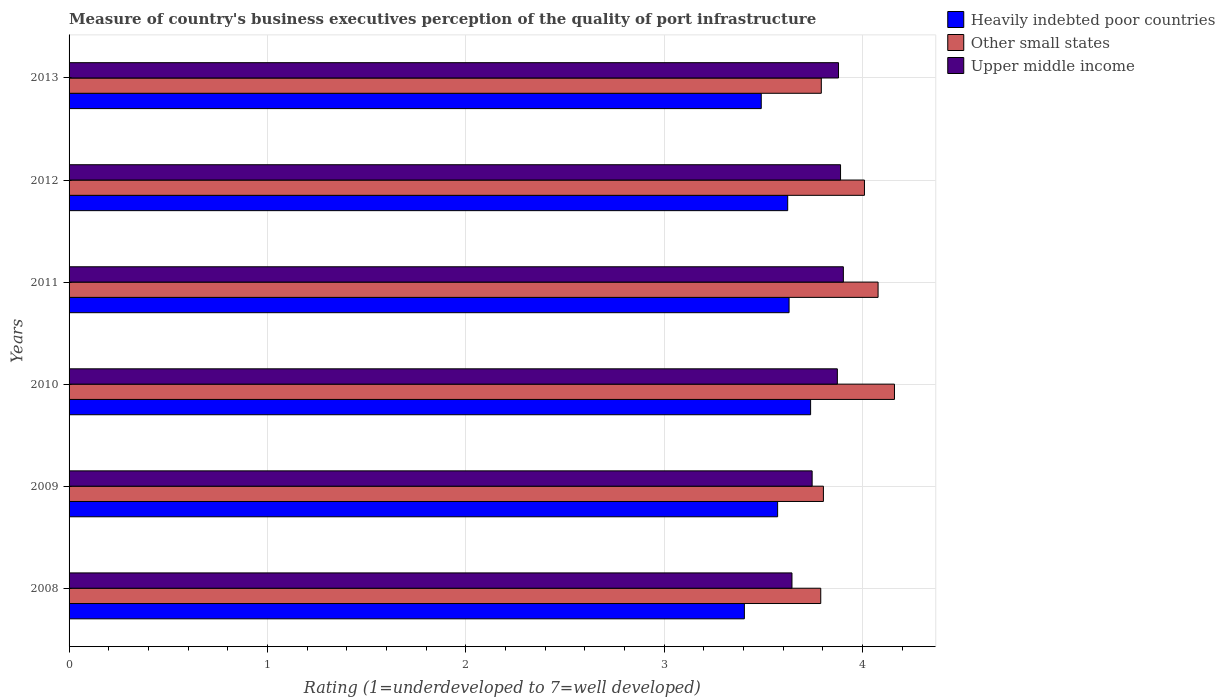How many different coloured bars are there?
Your answer should be very brief. 3. How many bars are there on the 5th tick from the top?
Your answer should be compact. 3. What is the label of the 6th group of bars from the top?
Your answer should be compact. 2008. What is the ratings of the quality of port infrastructure in Heavily indebted poor countries in 2011?
Your response must be concise. 3.63. Across all years, what is the maximum ratings of the quality of port infrastructure in Other small states?
Ensure brevity in your answer.  4.16. Across all years, what is the minimum ratings of the quality of port infrastructure in Upper middle income?
Keep it short and to the point. 3.64. In which year was the ratings of the quality of port infrastructure in Upper middle income maximum?
Your answer should be compact. 2011. What is the total ratings of the quality of port infrastructure in Other small states in the graph?
Keep it short and to the point. 23.63. What is the difference between the ratings of the quality of port infrastructure in Upper middle income in 2009 and that in 2011?
Offer a terse response. -0.16. What is the difference between the ratings of the quality of port infrastructure in Heavily indebted poor countries in 2009 and the ratings of the quality of port infrastructure in Upper middle income in 2012?
Your answer should be compact. -0.32. What is the average ratings of the quality of port infrastructure in Other small states per year?
Keep it short and to the point. 3.94. In the year 2011, what is the difference between the ratings of the quality of port infrastructure in Other small states and ratings of the quality of port infrastructure in Upper middle income?
Provide a succinct answer. 0.17. What is the ratio of the ratings of the quality of port infrastructure in Other small states in 2009 to that in 2010?
Your answer should be compact. 0.91. What is the difference between the highest and the second highest ratings of the quality of port infrastructure in Upper middle income?
Keep it short and to the point. 0.01. What is the difference between the highest and the lowest ratings of the quality of port infrastructure in Other small states?
Your response must be concise. 0.37. In how many years, is the ratings of the quality of port infrastructure in Other small states greater than the average ratings of the quality of port infrastructure in Other small states taken over all years?
Provide a succinct answer. 3. Is the sum of the ratings of the quality of port infrastructure in Upper middle income in 2009 and 2010 greater than the maximum ratings of the quality of port infrastructure in Other small states across all years?
Your response must be concise. Yes. What does the 1st bar from the top in 2011 represents?
Provide a succinct answer. Upper middle income. What does the 1st bar from the bottom in 2011 represents?
Give a very brief answer. Heavily indebted poor countries. What is the difference between two consecutive major ticks on the X-axis?
Ensure brevity in your answer.  1. Are the values on the major ticks of X-axis written in scientific E-notation?
Provide a short and direct response. No. Where does the legend appear in the graph?
Your answer should be very brief. Top right. How many legend labels are there?
Give a very brief answer. 3. What is the title of the graph?
Your answer should be very brief. Measure of country's business executives perception of the quality of port infrastructure. What is the label or title of the X-axis?
Provide a succinct answer. Rating (1=underdeveloped to 7=well developed). What is the label or title of the Y-axis?
Your answer should be compact. Years. What is the Rating (1=underdeveloped to 7=well developed) of Heavily indebted poor countries in 2008?
Your answer should be very brief. 3.4. What is the Rating (1=underdeveloped to 7=well developed) in Other small states in 2008?
Give a very brief answer. 3.79. What is the Rating (1=underdeveloped to 7=well developed) in Upper middle income in 2008?
Keep it short and to the point. 3.64. What is the Rating (1=underdeveloped to 7=well developed) in Heavily indebted poor countries in 2009?
Offer a terse response. 3.57. What is the Rating (1=underdeveloped to 7=well developed) in Other small states in 2009?
Keep it short and to the point. 3.8. What is the Rating (1=underdeveloped to 7=well developed) of Upper middle income in 2009?
Give a very brief answer. 3.75. What is the Rating (1=underdeveloped to 7=well developed) of Heavily indebted poor countries in 2010?
Offer a very short reply. 3.74. What is the Rating (1=underdeveloped to 7=well developed) in Other small states in 2010?
Make the answer very short. 4.16. What is the Rating (1=underdeveloped to 7=well developed) in Upper middle income in 2010?
Your answer should be very brief. 3.87. What is the Rating (1=underdeveloped to 7=well developed) in Heavily indebted poor countries in 2011?
Your answer should be very brief. 3.63. What is the Rating (1=underdeveloped to 7=well developed) in Other small states in 2011?
Your answer should be very brief. 4.08. What is the Rating (1=underdeveloped to 7=well developed) in Upper middle income in 2011?
Keep it short and to the point. 3.9. What is the Rating (1=underdeveloped to 7=well developed) in Heavily indebted poor countries in 2012?
Your answer should be very brief. 3.62. What is the Rating (1=underdeveloped to 7=well developed) in Other small states in 2012?
Your answer should be very brief. 4.01. What is the Rating (1=underdeveloped to 7=well developed) of Upper middle income in 2012?
Your response must be concise. 3.89. What is the Rating (1=underdeveloped to 7=well developed) of Heavily indebted poor countries in 2013?
Your answer should be compact. 3.49. What is the Rating (1=underdeveloped to 7=well developed) of Other small states in 2013?
Your answer should be very brief. 3.79. What is the Rating (1=underdeveloped to 7=well developed) of Upper middle income in 2013?
Your answer should be compact. 3.88. Across all years, what is the maximum Rating (1=underdeveloped to 7=well developed) in Heavily indebted poor countries?
Give a very brief answer. 3.74. Across all years, what is the maximum Rating (1=underdeveloped to 7=well developed) in Other small states?
Your answer should be very brief. 4.16. Across all years, what is the maximum Rating (1=underdeveloped to 7=well developed) of Upper middle income?
Offer a terse response. 3.9. Across all years, what is the minimum Rating (1=underdeveloped to 7=well developed) of Heavily indebted poor countries?
Give a very brief answer. 3.4. Across all years, what is the minimum Rating (1=underdeveloped to 7=well developed) of Other small states?
Provide a succinct answer. 3.79. Across all years, what is the minimum Rating (1=underdeveloped to 7=well developed) of Upper middle income?
Provide a short and direct response. 3.64. What is the total Rating (1=underdeveloped to 7=well developed) in Heavily indebted poor countries in the graph?
Offer a terse response. 21.45. What is the total Rating (1=underdeveloped to 7=well developed) in Other small states in the graph?
Your response must be concise. 23.63. What is the total Rating (1=underdeveloped to 7=well developed) in Upper middle income in the graph?
Your response must be concise. 22.93. What is the difference between the Rating (1=underdeveloped to 7=well developed) in Heavily indebted poor countries in 2008 and that in 2009?
Provide a succinct answer. -0.17. What is the difference between the Rating (1=underdeveloped to 7=well developed) in Other small states in 2008 and that in 2009?
Your answer should be compact. -0.01. What is the difference between the Rating (1=underdeveloped to 7=well developed) in Upper middle income in 2008 and that in 2009?
Your answer should be compact. -0.1. What is the difference between the Rating (1=underdeveloped to 7=well developed) of Heavily indebted poor countries in 2008 and that in 2010?
Your response must be concise. -0.33. What is the difference between the Rating (1=underdeveloped to 7=well developed) of Other small states in 2008 and that in 2010?
Ensure brevity in your answer.  -0.37. What is the difference between the Rating (1=underdeveloped to 7=well developed) of Upper middle income in 2008 and that in 2010?
Ensure brevity in your answer.  -0.23. What is the difference between the Rating (1=underdeveloped to 7=well developed) in Heavily indebted poor countries in 2008 and that in 2011?
Offer a very short reply. -0.23. What is the difference between the Rating (1=underdeveloped to 7=well developed) of Other small states in 2008 and that in 2011?
Your response must be concise. -0.29. What is the difference between the Rating (1=underdeveloped to 7=well developed) in Upper middle income in 2008 and that in 2011?
Ensure brevity in your answer.  -0.26. What is the difference between the Rating (1=underdeveloped to 7=well developed) in Heavily indebted poor countries in 2008 and that in 2012?
Your response must be concise. -0.22. What is the difference between the Rating (1=underdeveloped to 7=well developed) in Other small states in 2008 and that in 2012?
Offer a very short reply. -0.22. What is the difference between the Rating (1=underdeveloped to 7=well developed) of Upper middle income in 2008 and that in 2012?
Offer a terse response. -0.24. What is the difference between the Rating (1=underdeveloped to 7=well developed) of Heavily indebted poor countries in 2008 and that in 2013?
Give a very brief answer. -0.09. What is the difference between the Rating (1=underdeveloped to 7=well developed) in Other small states in 2008 and that in 2013?
Keep it short and to the point. -0. What is the difference between the Rating (1=underdeveloped to 7=well developed) in Upper middle income in 2008 and that in 2013?
Offer a very short reply. -0.23. What is the difference between the Rating (1=underdeveloped to 7=well developed) of Heavily indebted poor countries in 2009 and that in 2010?
Keep it short and to the point. -0.17. What is the difference between the Rating (1=underdeveloped to 7=well developed) in Other small states in 2009 and that in 2010?
Keep it short and to the point. -0.36. What is the difference between the Rating (1=underdeveloped to 7=well developed) of Upper middle income in 2009 and that in 2010?
Provide a succinct answer. -0.13. What is the difference between the Rating (1=underdeveloped to 7=well developed) in Heavily indebted poor countries in 2009 and that in 2011?
Offer a very short reply. -0.06. What is the difference between the Rating (1=underdeveloped to 7=well developed) in Other small states in 2009 and that in 2011?
Offer a very short reply. -0.28. What is the difference between the Rating (1=underdeveloped to 7=well developed) in Upper middle income in 2009 and that in 2011?
Provide a succinct answer. -0.16. What is the difference between the Rating (1=underdeveloped to 7=well developed) of Heavily indebted poor countries in 2009 and that in 2012?
Provide a succinct answer. -0.05. What is the difference between the Rating (1=underdeveloped to 7=well developed) of Other small states in 2009 and that in 2012?
Your answer should be compact. -0.21. What is the difference between the Rating (1=underdeveloped to 7=well developed) of Upper middle income in 2009 and that in 2012?
Ensure brevity in your answer.  -0.14. What is the difference between the Rating (1=underdeveloped to 7=well developed) in Heavily indebted poor countries in 2009 and that in 2013?
Your response must be concise. 0.08. What is the difference between the Rating (1=underdeveloped to 7=well developed) of Other small states in 2009 and that in 2013?
Offer a terse response. 0.01. What is the difference between the Rating (1=underdeveloped to 7=well developed) of Upper middle income in 2009 and that in 2013?
Keep it short and to the point. -0.13. What is the difference between the Rating (1=underdeveloped to 7=well developed) of Heavily indebted poor countries in 2010 and that in 2011?
Offer a very short reply. 0.11. What is the difference between the Rating (1=underdeveloped to 7=well developed) in Other small states in 2010 and that in 2011?
Your answer should be compact. 0.08. What is the difference between the Rating (1=underdeveloped to 7=well developed) of Upper middle income in 2010 and that in 2011?
Offer a terse response. -0.03. What is the difference between the Rating (1=underdeveloped to 7=well developed) in Heavily indebted poor countries in 2010 and that in 2012?
Keep it short and to the point. 0.12. What is the difference between the Rating (1=underdeveloped to 7=well developed) in Other small states in 2010 and that in 2012?
Your response must be concise. 0.15. What is the difference between the Rating (1=underdeveloped to 7=well developed) in Upper middle income in 2010 and that in 2012?
Your answer should be compact. -0.02. What is the difference between the Rating (1=underdeveloped to 7=well developed) in Heavily indebted poor countries in 2010 and that in 2013?
Provide a succinct answer. 0.25. What is the difference between the Rating (1=underdeveloped to 7=well developed) of Other small states in 2010 and that in 2013?
Keep it short and to the point. 0.37. What is the difference between the Rating (1=underdeveloped to 7=well developed) of Upper middle income in 2010 and that in 2013?
Your response must be concise. -0.01. What is the difference between the Rating (1=underdeveloped to 7=well developed) in Heavily indebted poor countries in 2011 and that in 2012?
Offer a terse response. 0.01. What is the difference between the Rating (1=underdeveloped to 7=well developed) in Other small states in 2011 and that in 2012?
Your answer should be very brief. 0.07. What is the difference between the Rating (1=underdeveloped to 7=well developed) of Upper middle income in 2011 and that in 2012?
Offer a very short reply. 0.01. What is the difference between the Rating (1=underdeveloped to 7=well developed) in Heavily indebted poor countries in 2011 and that in 2013?
Offer a very short reply. 0.14. What is the difference between the Rating (1=underdeveloped to 7=well developed) in Other small states in 2011 and that in 2013?
Make the answer very short. 0.29. What is the difference between the Rating (1=underdeveloped to 7=well developed) of Upper middle income in 2011 and that in 2013?
Give a very brief answer. 0.02. What is the difference between the Rating (1=underdeveloped to 7=well developed) of Heavily indebted poor countries in 2012 and that in 2013?
Your response must be concise. 0.13. What is the difference between the Rating (1=underdeveloped to 7=well developed) of Other small states in 2012 and that in 2013?
Ensure brevity in your answer.  0.22. What is the difference between the Rating (1=underdeveloped to 7=well developed) of Upper middle income in 2012 and that in 2013?
Your answer should be compact. 0.01. What is the difference between the Rating (1=underdeveloped to 7=well developed) of Heavily indebted poor countries in 2008 and the Rating (1=underdeveloped to 7=well developed) of Other small states in 2009?
Give a very brief answer. -0.4. What is the difference between the Rating (1=underdeveloped to 7=well developed) of Heavily indebted poor countries in 2008 and the Rating (1=underdeveloped to 7=well developed) of Upper middle income in 2009?
Your answer should be compact. -0.34. What is the difference between the Rating (1=underdeveloped to 7=well developed) in Other small states in 2008 and the Rating (1=underdeveloped to 7=well developed) in Upper middle income in 2009?
Keep it short and to the point. 0.04. What is the difference between the Rating (1=underdeveloped to 7=well developed) in Heavily indebted poor countries in 2008 and the Rating (1=underdeveloped to 7=well developed) in Other small states in 2010?
Make the answer very short. -0.76. What is the difference between the Rating (1=underdeveloped to 7=well developed) in Heavily indebted poor countries in 2008 and the Rating (1=underdeveloped to 7=well developed) in Upper middle income in 2010?
Your response must be concise. -0.47. What is the difference between the Rating (1=underdeveloped to 7=well developed) in Other small states in 2008 and the Rating (1=underdeveloped to 7=well developed) in Upper middle income in 2010?
Ensure brevity in your answer.  -0.08. What is the difference between the Rating (1=underdeveloped to 7=well developed) of Heavily indebted poor countries in 2008 and the Rating (1=underdeveloped to 7=well developed) of Other small states in 2011?
Provide a succinct answer. -0.67. What is the difference between the Rating (1=underdeveloped to 7=well developed) of Heavily indebted poor countries in 2008 and the Rating (1=underdeveloped to 7=well developed) of Upper middle income in 2011?
Make the answer very short. -0.5. What is the difference between the Rating (1=underdeveloped to 7=well developed) of Other small states in 2008 and the Rating (1=underdeveloped to 7=well developed) of Upper middle income in 2011?
Give a very brief answer. -0.11. What is the difference between the Rating (1=underdeveloped to 7=well developed) of Heavily indebted poor countries in 2008 and the Rating (1=underdeveloped to 7=well developed) of Other small states in 2012?
Make the answer very short. -0.61. What is the difference between the Rating (1=underdeveloped to 7=well developed) in Heavily indebted poor countries in 2008 and the Rating (1=underdeveloped to 7=well developed) in Upper middle income in 2012?
Your response must be concise. -0.48. What is the difference between the Rating (1=underdeveloped to 7=well developed) of Other small states in 2008 and the Rating (1=underdeveloped to 7=well developed) of Upper middle income in 2012?
Your response must be concise. -0.1. What is the difference between the Rating (1=underdeveloped to 7=well developed) in Heavily indebted poor countries in 2008 and the Rating (1=underdeveloped to 7=well developed) in Other small states in 2013?
Provide a short and direct response. -0.39. What is the difference between the Rating (1=underdeveloped to 7=well developed) of Heavily indebted poor countries in 2008 and the Rating (1=underdeveloped to 7=well developed) of Upper middle income in 2013?
Provide a succinct answer. -0.47. What is the difference between the Rating (1=underdeveloped to 7=well developed) in Other small states in 2008 and the Rating (1=underdeveloped to 7=well developed) in Upper middle income in 2013?
Keep it short and to the point. -0.09. What is the difference between the Rating (1=underdeveloped to 7=well developed) in Heavily indebted poor countries in 2009 and the Rating (1=underdeveloped to 7=well developed) in Other small states in 2010?
Your answer should be very brief. -0.59. What is the difference between the Rating (1=underdeveloped to 7=well developed) of Heavily indebted poor countries in 2009 and the Rating (1=underdeveloped to 7=well developed) of Upper middle income in 2010?
Your answer should be very brief. -0.3. What is the difference between the Rating (1=underdeveloped to 7=well developed) in Other small states in 2009 and the Rating (1=underdeveloped to 7=well developed) in Upper middle income in 2010?
Make the answer very short. -0.07. What is the difference between the Rating (1=underdeveloped to 7=well developed) in Heavily indebted poor countries in 2009 and the Rating (1=underdeveloped to 7=well developed) in Other small states in 2011?
Give a very brief answer. -0.51. What is the difference between the Rating (1=underdeveloped to 7=well developed) of Heavily indebted poor countries in 2009 and the Rating (1=underdeveloped to 7=well developed) of Upper middle income in 2011?
Offer a terse response. -0.33. What is the difference between the Rating (1=underdeveloped to 7=well developed) of Other small states in 2009 and the Rating (1=underdeveloped to 7=well developed) of Upper middle income in 2011?
Your response must be concise. -0.1. What is the difference between the Rating (1=underdeveloped to 7=well developed) of Heavily indebted poor countries in 2009 and the Rating (1=underdeveloped to 7=well developed) of Other small states in 2012?
Your answer should be very brief. -0.44. What is the difference between the Rating (1=underdeveloped to 7=well developed) in Heavily indebted poor countries in 2009 and the Rating (1=underdeveloped to 7=well developed) in Upper middle income in 2012?
Provide a short and direct response. -0.32. What is the difference between the Rating (1=underdeveloped to 7=well developed) in Other small states in 2009 and the Rating (1=underdeveloped to 7=well developed) in Upper middle income in 2012?
Provide a short and direct response. -0.09. What is the difference between the Rating (1=underdeveloped to 7=well developed) in Heavily indebted poor countries in 2009 and the Rating (1=underdeveloped to 7=well developed) in Other small states in 2013?
Your response must be concise. -0.22. What is the difference between the Rating (1=underdeveloped to 7=well developed) of Heavily indebted poor countries in 2009 and the Rating (1=underdeveloped to 7=well developed) of Upper middle income in 2013?
Give a very brief answer. -0.31. What is the difference between the Rating (1=underdeveloped to 7=well developed) in Other small states in 2009 and the Rating (1=underdeveloped to 7=well developed) in Upper middle income in 2013?
Provide a succinct answer. -0.08. What is the difference between the Rating (1=underdeveloped to 7=well developed) in Heavily indebted poor countries in 2010 and the Rating (1=underdeveloped to 7=well developed) in Other small states in 2011?
Your answer should be compact. -0.34. What is the difference between the Rating (1=underdeveloped to 7=well developed) of Heavily indebted poor countries in 2010 and the Rating (1=underdeveloped to 7=well developed) of Upper middle income in 2011?
Your answer should be compact. -0.17. What is the difference between the Rating (1=underdeveloped to 7=well developed) in Other small states in 2010 and the Rating (1=underdeveloped to 7=well developed) in Upper middle income in 2011?
Give a very brief answer. 0.26. What is the difference between the Rating (1=underdeveloped to 7=well developed) in Heavily indebted poor countries in 2010 and the Rating (1=underdeveloped to 7=well developed) in Other small states in 2012?
Your answer should be very brief. -0.27. What is the difference between the Rating (1=underdeveloped to 7=well developed) of Heavily indebted poor countries in 2010 and the Rating (1=underdeveloped to 7=well developed) of Upper middle income in 2012?
Your response must be concise. -0.15. What is the difference between the Rating (1=underdeveloped to 7=well developed) of Other small states in 2010 and the Rating (1=underdeveloped to 7=well developed) of Upper middle income in 2012?
Make the answer very short. 0.27. What is the difference between the Rating (1=underdeveloped to 7=well developed) of Heavily indebted poor countries in 2010 and the Rating (1=underdeveloped to 7=well developed) of Other small states in 2013?
Give a very brief answer. -0.05. What is the difference between the Rating (1=underdeveloped to 7=well developed) in Heavily indebted poor countries in 2010 and the Rating (1=underdeveloped to 7=well developed) in Upper middle income in 2013?
Offer a very short reply. -0.14. What is the difference between the Rating (1=underdeveloped to 7=well developed) in Other small states in 2010 and the Rating (1=underdeveloped to 7=well developed) in Upper middle income in 2013?
Offer a terse response. 0.28. What is the difference between the Rating (1=underdeveloped to 7=well developed) of Heavily indebted poor countries in 2011 and the Rating (1=underdeveloped to 7=well developed) of Other small states in 2012?
Provide a short and direct response. -0.38. What is the difference between the Rating (1=underdeveloped to 7=well developed) of Heavily indebted poor countries in 2011 and the Rating (1=underdeveloped to 7=well developed) of Upper middle income in 2012?
Provide a short and direct response. -0.26. What is the difference between the Rating (1=underdeveloped to 7=well developed) in Other small states in 2011 and the Rating (1=underdeveloped to 7=well developed) in Upper middle income in 2012?
Provide a succinct answer. 0.19. What is the difference between the Rating (1=underdeveloped to 7=well developed) of Heavily indebted poor countries in 2011 and the Rating (1=underdeveloped to 7=well developed) of Other small states in 2013?
Offer a terse response. -0.16. What is the difference between the Rating (1=underdeveloped to 7=well developed) in Heavily indebted poor countries in 2011 and the Rating (1=underdeveloped to 7=well developed) in Upper middle income in 2013?
Keep it short and to the point. -0.25. What is the difference between the Rating (1=underdeveloped to 7=well developed) in Other small states in 2011 and the Rating (1=underdeveloped to 7=well developed) in Upper middle income in 2013?
Your response must be concise. 0.2. What is the difference between the Rating (1=underdeveloped to 7=well developed) in Heavily indebted poor countries in 2012 and the Rating (1=underdeveloped to 7=well developed) in Other small states in 2013?
Provide a short and direct response. -0.17. What is the difference between the Rating (1=underdeveloped to 7=well developed) in Heavily indebted poor countries in 2012 and the Rating (1=underdeveloped to 7=well developed) in Upper middle income in 2013?
Your answer should be compact. -0.26. What is the difference between the Rating (1=underdeveloped to 7=well developed) of Other small states in 2012 and the Rating (1=underdeveloped to 7=well developed) of Upper middle income in 2013?
Your answer should be very brief. 0.13. What is the average Rating (1=underdeveloped to 7=well developed) in Heavily indebted poor countries per year?
Your answer should be compact. 3.58. What is the average Rating (1=underdeveloped to 7=well developed) in Other small states per year?
Provide a short and direct response. 3.94. What is the average Rating (1=underdeveloped to 7=well developed) of Upper middle income per year?
Your answer should be compact. 3.82. In the year 2008, what is the difference between the Rating (1=underdeveloped to 7=well developed) of Heavily indebted poor countries and Rating (1=underdeveloped to 7=well developed) of Other small states?
Make the answer very short. -0.39. In the year 2008, what is the difference between the Rating (1=underdeveloped to 7=well developed) in Heavily indebted poor countries and Rating (1=underdeveloped to 7=well developed) in Upper middle income?
Your answer should be very brief. -0.24. In the year 2008, what is the difference between the Rating (1=underdeveloped to 7=well developed) of Other small states and Rating (1=underdeveloped to 7=well developed) of Upper middle income?
Ensure brevity in your answer.  0.15. In the year 2009, what is the difference between the Rating (1=underdeveloped to 7=well developed) of Heavily indebted poor countries and Rating (1=underdeveloped to 7=well developed) of Other small states?
Your answer should be compact. -0.23. In the year 2009, what is the difference between the Rating (1=underdeveloped to 7=well developed) in Heavily indebted poor countries and Rating (1=underdeveloped to 7=well developed) in Upper middle income?
Offer a terse response. -0.17. In the year 2009, what is the difference between the Rating (1=underdeveloped to 7=well developed) in Other small states and Rating (1=underdeveloped to 7=well developed) in Upper middle income?
Your response must be concise. 0.06. In the year 2010, what is the difference between the Rating (1=underdeveloped to 7=well developed) in Heavily indebted poor countries and Rating (1=underdeveloped to 7=well developed) in Other small states?
Offer a very short reply. -0.42. In the year 2010, what is the difference between the Rating (1=underdeveloped to 7=well developed) in Heavily indebted poor countries and Rating (1=underdeveloped to 7=well developed) in Upper middle income?
Provide a succinct answer. -0.13. In the year 2010, what is the difference between the Rating (1=underdeveloped to 7=well developed) in Other small states and Rating (1=underdeveloped to 7=well developed) in Upper middle income?
Your answer should be very brief. 0.29. In the year 2011, what is the difference between the Rating (1=underdeveloped to 7=well developed) in Heavily indebted poor countries and Rating (1=underdeveloped to 7=well developed) in Other small states?
Provide a succinct answer. -0.45. In the year 2011, what is the difference between the Rating (1=underdeveloped to 7=well developed) in Heavily indebted poor countries and Rating (1=underdeveloped to 7=well developed) in Upper middle income?
Your response must be concise. -0.27. In the year 2011, what is the difference between the Rating (1=underdeveloped to 7=well developed) in Other small states and Rating (1=underdeveloped to 7=well developed) in Upper middle income?
Offer a very short reply. 0.17. In the year 2012, what is the difference between the Rating (1=underdeveloped to 7=well developed) in Heavily indebted poor countries and Rating (1=underdeveloped to 7=well developed) in Other small states?
Your answer should be compact. -0.39. In the year 2012, what is the difference between the Rating (1=underdeveloped to 7=well developed) of Heavily indebted poor countries and Rating (1=underdeveloped to 7=well developed) of Upper middle income?
Offer a very short reply. -0.27. In the year 2012, what is the difference between the Rating (1=underdeveloped to 7=well developed) in Other small states and Rating (1=underdeveloped to 7=well developed) in Upper middle income?
Your response must be concise. 0.12. In the year 2013, what is the difference between the Rating (1=underdeveloped to 7=well developed) in Heavily indebted poor countries and Rating (1=underdeveloped to 7=well developed) in Other small states?
Provide a succinct answer. -0.3. In the year 2013, what is the difference between the Rating (1=underdeveloped to 7=well developed) in Heavily indebted poor countries and Rating (1=underdeveloped to 7=well developed) in Upper middle income?
Your answer should be very brief. -0.39. In the year 2013, what is the difference between the Rating (1=underdeveloped to 7=well developed) of Other small states and Rating (1=underdeveloped to 7=well developed) of Upper middle income?
Offer a very short reply. -0.09. What is the ratio of the Rating (1=underdeveloped to 7=well developed) of Heavily indebted poor countries in 2008 to that in 2009?
Offer a very short reply. 0.95. What is the ratio of the Rating (1=underdeveloped to 7=well developed) of Other small states in 2008 to that in 2009?
Offer a very short reply. 1. What is the ratio of the Rating (1=underdeveloped to 7=well developed) of Upper middle income in 2008 to that in 2009?
Offer a terse response. 0.97. What is the ratio of the Rating (1=underdeveloped to 7=well developed) of Heavily indebted poor countries in 2008 to that in 2010?
Your response must be concise. 0.91. What is the ratio of the Rating (1=underdeveloped to 7=well developed) in Other small states in 2008 to that in 2010?
Provide a succinct answer. 0.91. What is the ratio of the Rating (1=underdeveloped to 7=well developed) in Upper middle income in 2008 to that in 2010?
Your answer should be very brief. 0.94. What is the ratio of the Rating (1=underdeveloped to 7=well developed) in Heavily indebted poor countries in 2008 to that in 2011?
Offer a very short reply. 0.94. What is the ratio of the Rating (1=underdeveloped to 7=well developed) of Other small states in 2008 to that in 2011?
Offer a very short reply. 0.93. What is the ratio of the Rating (1=underdeveloped to 7=well developed) in Upper middle income in 2008 to that in 2011?
Give a very brief answer. 0.93. What is the ratio of the Rating (1=underdeveloped to 7=well developed) of Heavily indebted poor countries in 2008 to that in 2012?
Offer a very short reply. 0.94. What is the ratio of the Rating (1=underdeveloped to 7=well developed) in Other small states in 2008 to that in 2012?
Provide a succinct answer. 0.95. What is the ratio of the Rating (1=underdeveloped to 7=well developed) in Upper middle income in 2008 to that in 2012?
Make the answer very short. 0.94. What is the ratio of the Rating (1=underdeveloped to 7=well developed) in Heavily indebted poor countries in 2008 to that in 2013?
Make the answer very short. 0.98. What is the ratio of the Rating (1=underdeveloped to 7=well developed) of Upper middle income in 2008 to that in 2013?
Make the answer very short. 0.94. What is the ratio of the Rating (1=underdeveloped to 7=well developed) of Heavily indebted poor countries in 2009 to that in 2010?
Offer a very short reply. 0.96. What is the ratio of the Rating (1=underdeveloped to 7=well developed) in Other small states in 2009 to that in 2010?
Your response must be concise. 0.91. What is the ratio of the Rating (1=underdeveloped to 7=well developed) of Upper middle income in 2009 to that in 2010?
Your answer should be compact. 0.97. What is the ratio of the Rating (1=underdeveloped to 7=well developed) in Heavily indebted poor countries in 2009 to that in 2011?
Offer a terse response. 0.98. What is the ratio of the Rating (1=underdeveloped to 7=well developed) in Other small states in 2009 to that in 2011?
Your response must be concise. 0.93. What is the ratio of the Rating (1=underdeveloped to 7=well developed) in Upper middle income in 2009 to that in 2011?
Your answer should be compact. 0.96. What is the ratio of the Rating (1=underdeveloped to 7=well developed) of Heavily indebted poor countries in 2009 to that in 2012?
Keep it short and to the point. 0.99. What is the ratio of the Rating (1=underdeveloped to 7=well developed) of Other small states in 2009 to that in 2012?
Provide a short and direct response. 0.95. What is the ratio of the Rating (1=underdeveloped to 7=well developed) of Upper middle income in 2009 to that in 2012?
Ensure brevity in your answer.  0.96. What is the ratio of the Rating (1=underdeveloped to 7=well developed) of Heavily indebted poor countries in 2009 to that in 2013?
Offer a terse response. 1.02. What is the ratio of the Rating (1=underdeveloped to 7=well developed) of Upper middle income in 2009 to that in 2013?
Give a very brief answer. 0.97. What is the ratio of the Rating (1=underdeveloped to 7=well developed) of Heavily indebted poor countries in 2010 to that in 2011?
Your answer should be compact. 1.03. What is the ratio of the Rating (1=underdeveloped to 7=well developed) of Other small states in 2010 to that in 2011?
Provide a succinct answer. 1.02. What is the ratio of the Rating (1=underdeveloped to 7=well developed) in Heavily indebted poor countries in 2010 to that in 2012?
Your answer should be very brief. 1.03. What is the ratio of the Rating (1=underdeveloped to 7=well developed) of Other small states in 2010 to that in 2012?
Offer a terse response. 1.04. What is the ratio of the Rating (1=underdeveloped to 7=well developed) in Upper middle income in 2010 to that in 2012?
Your response must be concise. 1. What is the ratio of the Rating (1=underdeveloped to 7=well developed) in Heavily indebted poor countries in 2010 to that in 2013?
Your response must be concise. 1.07. What is the ratio of the Rating (1=underdeveloped to 7=well developed) of Other small states in 2010 to that in 2013?
Offer a terse response. 1.1. What is the ratio of the Rating (1=underdeveloped to 7=well developed) of Heavily indebted poor countries in 2011 to that in 2012?
Your response must be concise. 1. What is the ratio of the Rating (1=underdeveloped to 7=well developed) in Other small states in 2011 to that in 2012?
Provide a succinct answer. 1.02. What is the ratio of the Rating (1=underdeveloped to 7=well developed) in Upper middle income in 2011 to that in 2012?
Provide a short and direct response. 1. What is the ratio of the Rating (1=underdeveloped to 7=well developed) in Heavily indebted poor countries in 2011 to that in 2013?
Your answer should be very brief. 1.04. What is the ratio of the Rating (1=underdeveloped to 7=well developed) in Other small states in 2011 to that in 2013?
Your answer should be very brief. 1.08. What is the ratio of the Rating (1=underdeveloped to 7=well developed) in Upper middle income in 2011 to that in 2013?
Offer a terse response. 1.01. What is the ratio of the Rating (1=underdeveloped to 7=well developed) in Heavily indebted poor countries in 2012 to that in 2013?
Offer a terse response. 1.04. What is the ratio of the Rating (1=underdeveloped to 7=well developed) of Other small states in 2012 to that in 2013?
Your answer should be compact. 1.06. What is the difference between the highest and the second highest Rating (1=underdeveloped to 7=well developed) of Heavily indebted poor countries?
Offer a terse response. 0.11. What is the difference between the highest and the second highest Rating (1=underdeveloped to 7=well developed) in Other small states?
Your response must be concise. 0.08. What is the difference between the highest and the second highest Rating (1=underdeveloped to 7=well developed) in Upper middle income?
Provide a short and direct response. 0.01. What is the difference between the highest and the lowest Rating (1=underdeveloped to 7=well developed) in Heavily indebted poor countries?
Provide a short and direct response. 0.33. What is the difference between the highest and the lowest Rating (1=underdeveloped to 7=well developed) of Other small states?
Offer a very short reply. 0.37. What is the difference between the highest and the lowest Rating (1=underdeveloped to 7=well developed) of Upper middle income?
Your answer should be compact. 0.26. 